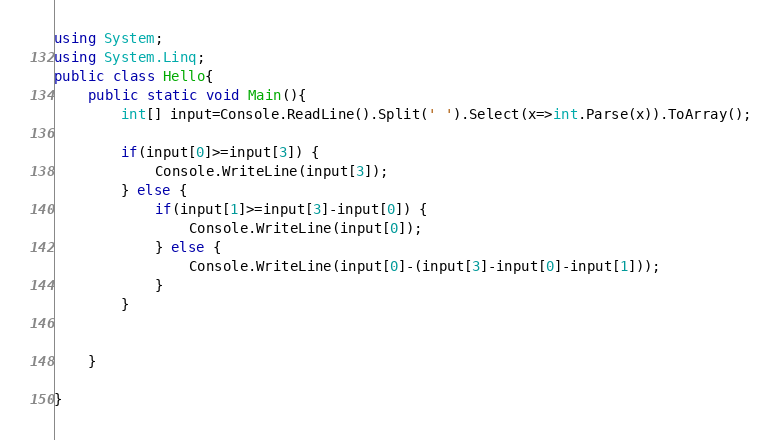<code> <loc_0><loc_0><loc_500><loc_500><_C#_>using System;
using System.Linq;
public class Hello{
    public static void Main(){
        int[] input=Console.ReadLine().Split(' ').Select(x=>int.Parse(x)).ToArray();
        
        if(input[0]>=input[3]) {
            Console.WriteLine(input[3]);
        } else {
            if(input[1]>=input[3]-input[0]) {
                Console.WriteLine(input[0]);   
            } else {
                Console.WriteLine(input[0]-(input[3]-input[0]-input[1]));
            }
        } 


    }
    
}
</code> 